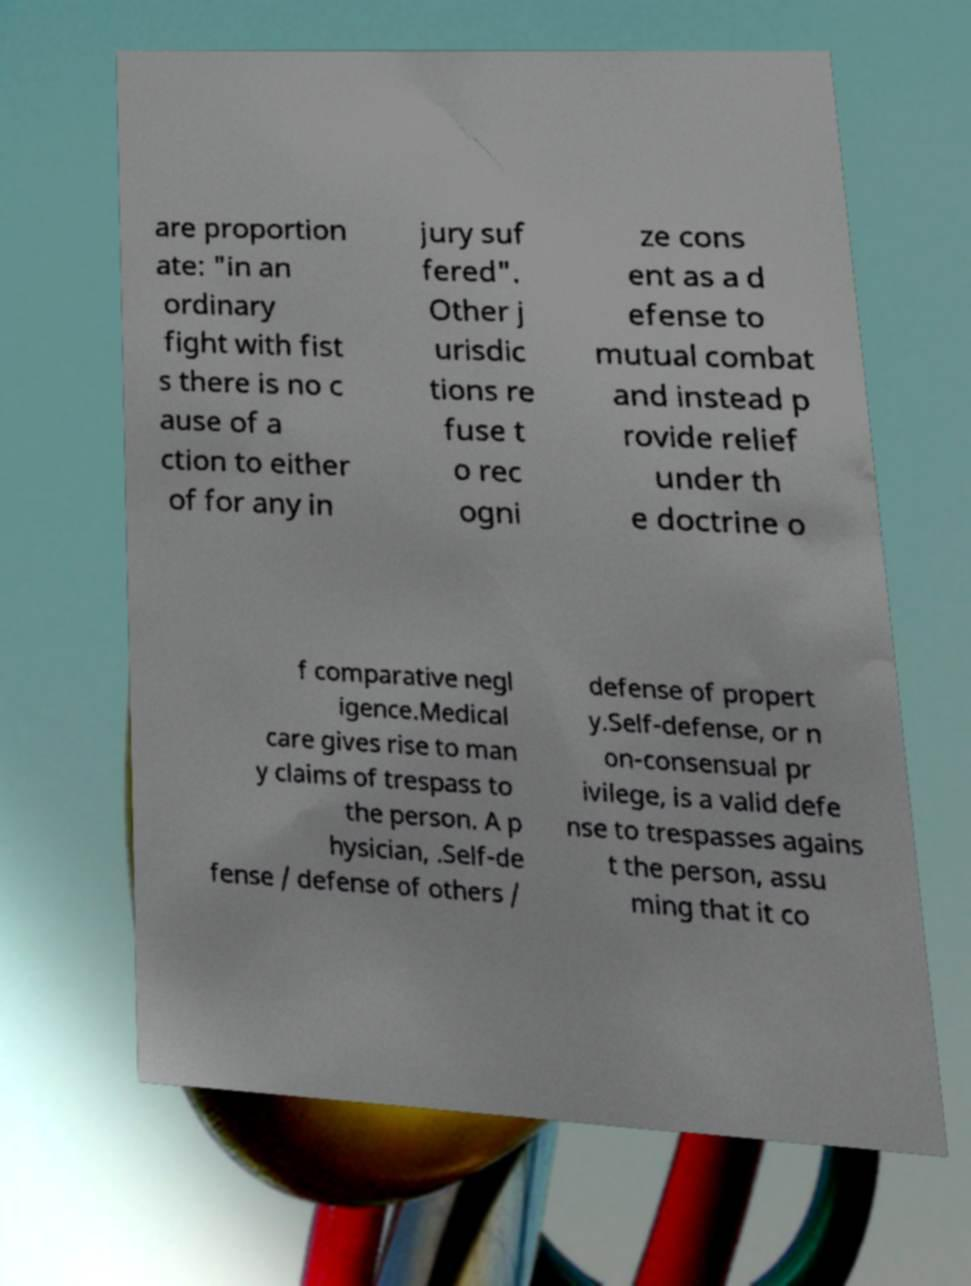Could you assist in decoding the text presented in this image and type it out clearly? are proportion ate: "in an ordinary fight with fist s there is no c ause of a ction to either of for any in jury suf fered". Other j urisdic tions re fuse t o rec ogni ze cons ent as a d efense to mutual combat and instead p rovide relief under th e doctrine o f comparative negl igence.Medical care gives rise to man y claims of trespass to the person. A p hysician, .Self-de fense / defense of others / defense of propert y.Self-defense, or n on-consensual pr ivilege, is a valid defe nse to trespasses agains t the person, assu ming that it co 